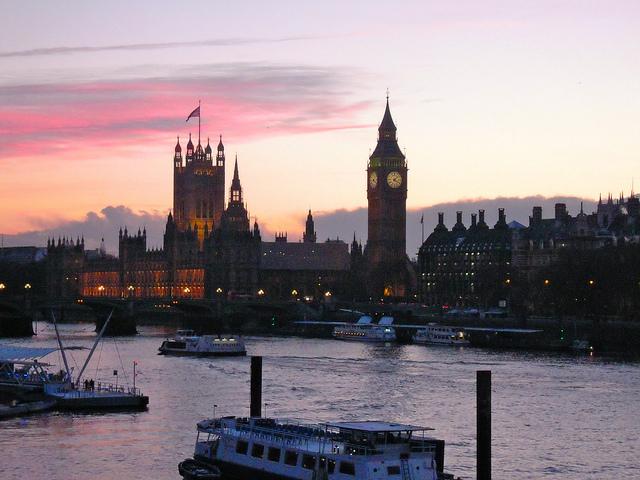Are there people in the boats?
Give a very brief answer. Yes. Are those sailboats?
Keep it brief. No. Can you see any boats?
Short answer required. Yes. Is the water choppy?
Keep it brief. No. What time of day was this picture taken?
Write a very short answer. Evening. 